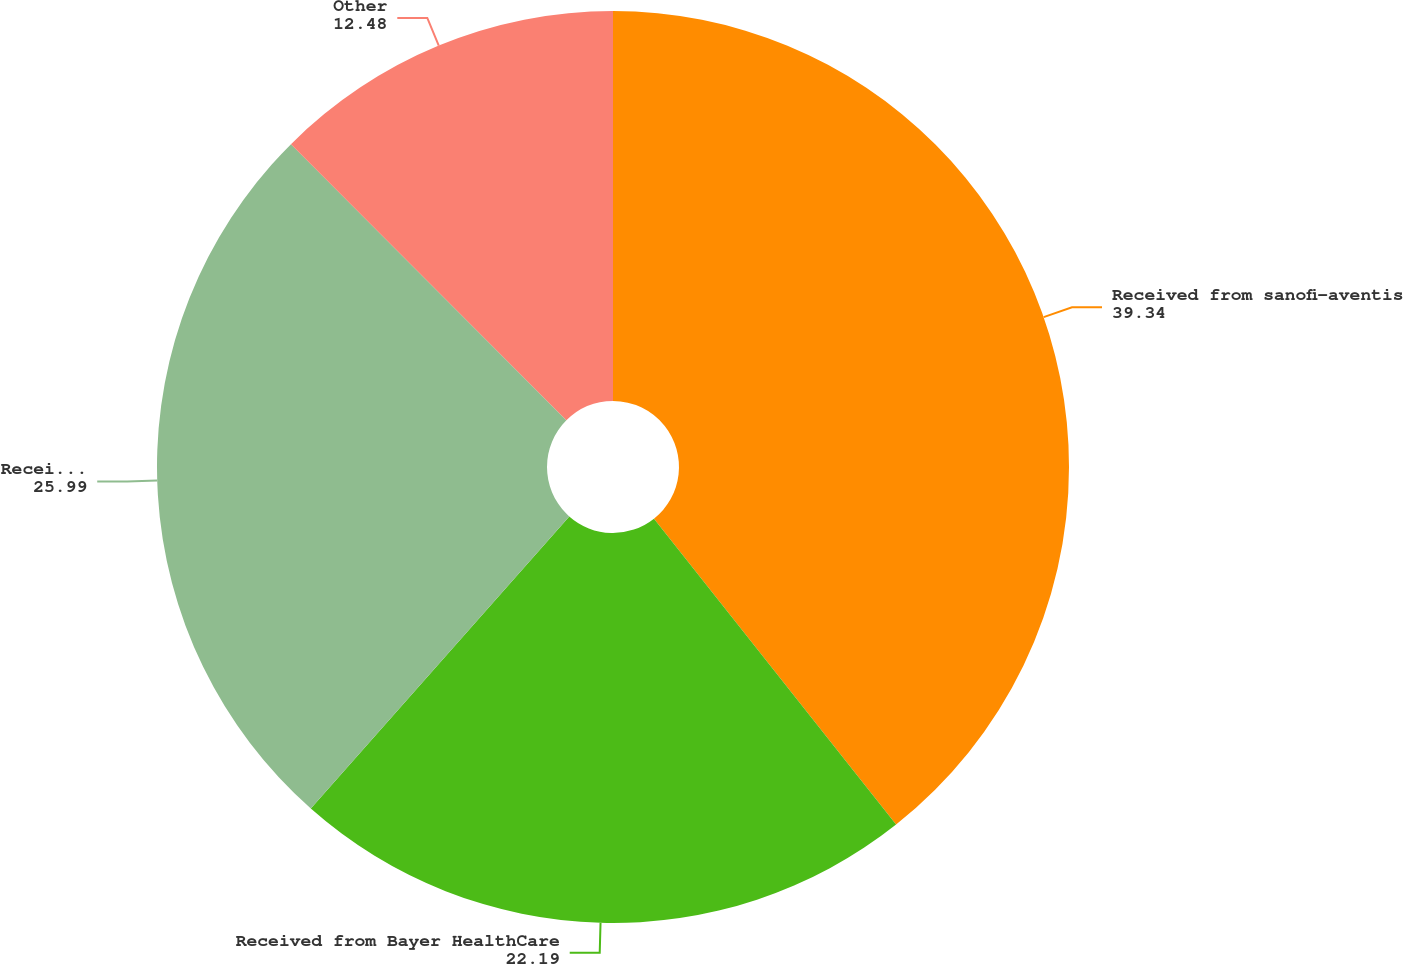Convert chart to OTSL. <chart><loc_0><loc_0><loc_500><loc_500><pie_chart><fcel>Received from sanofi-aventis<fcel>Received from Bayer HealthCare<fcel>Received for technology<fcel>Other<nl><fcel>39.34%<fcel>22.19%<fcel>25.99%<fcel>12.48%<nl></chart> 